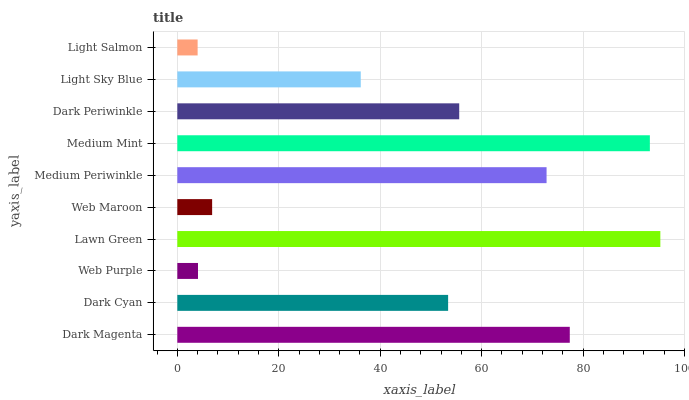Is Light Salmon the minimum?
Answer yes or no. Yes. Is Lawn Green the maximum?
Answer yes or no. Yes. Is Dark Cyan the minimum?
Answer yes or no. No. Is Dark Cyan the maximum?
Answer yes or no. No. Is Dark Magenta greater than Dark Cyan?
Answer yes or no. Yes. Is Dark Cyan less than Dark Magenta?
Answer yes or no. Yes. Is Dark Cyan greater than Dark Magenta?
Answer yes or no. No. Is Dark Magenta less than Dark Cyan?
Answer yes or no. No. Is Dark Periwinkle the high median?
Answer yes or no. Yes. Is Dark Cyan the low median?
Answer yes or no. Yes. Is Lawn Green the high median?
Answer yes or no. No. Is Dark Periwinkle the low median?
Answer yes or no. No. 